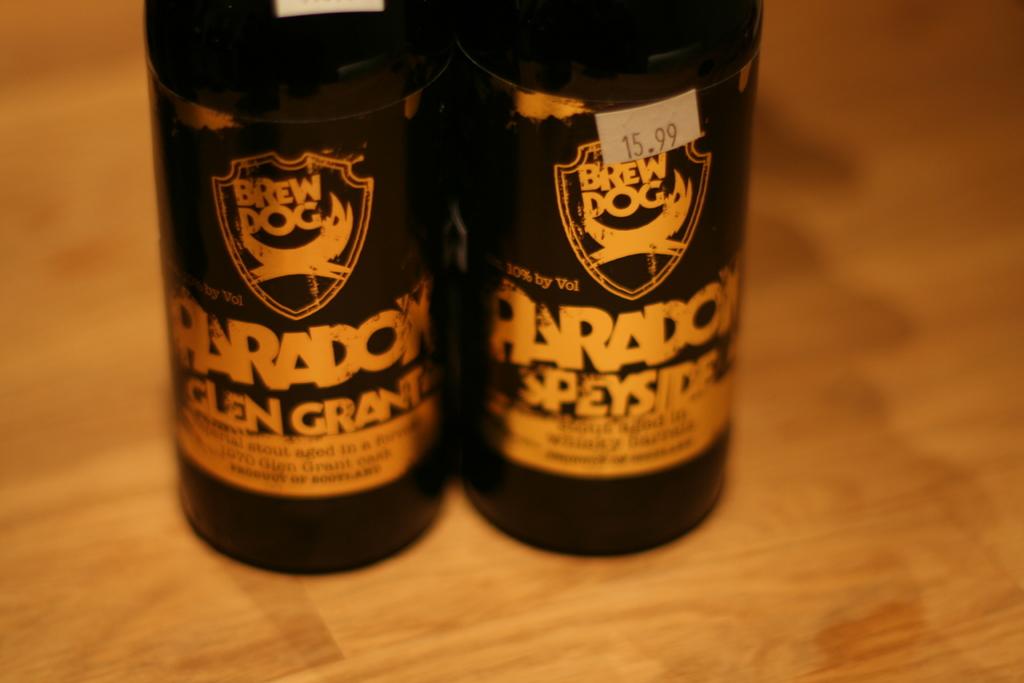Who is the brewery?
Offer a very short reply. Brew dog. What brand of beer is this?
Provide a short and direct response. Brew dog. 